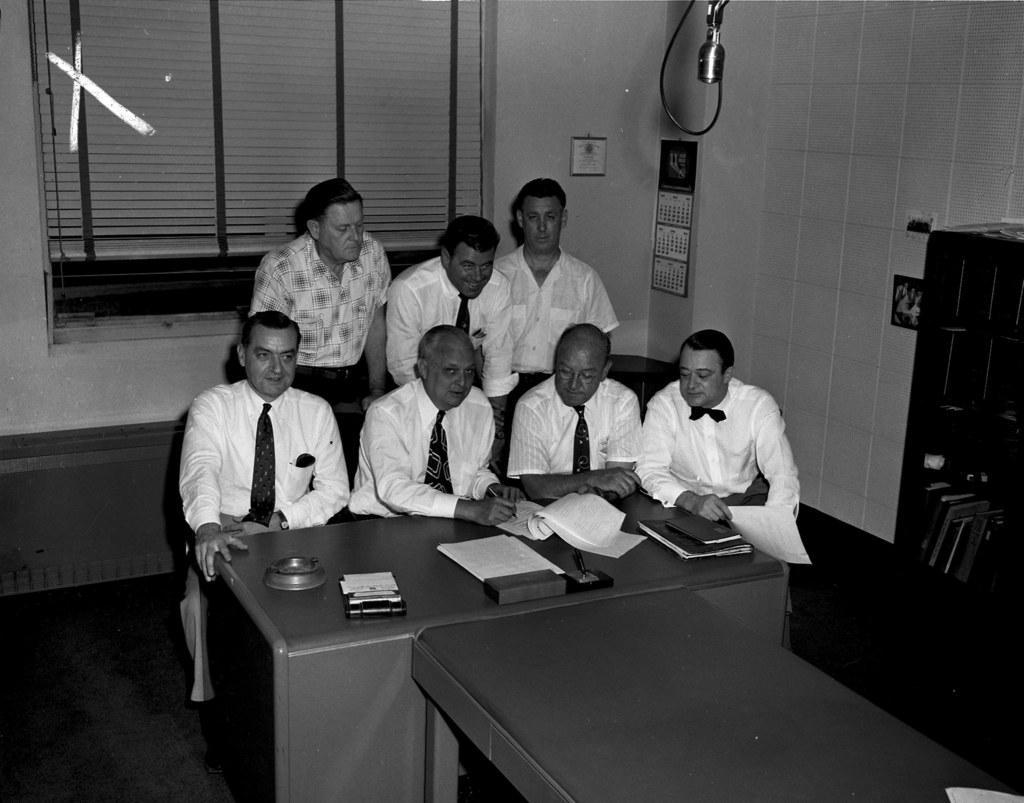Can you describe this image briefly? In this picture there are four members sitting in the chairs in front of a table on which some books, papers and files were placed. Four of them were men. Behind them there are three men standing. in the right side there is a bookshelf. In the background there is a window, curtain and a wall here. 